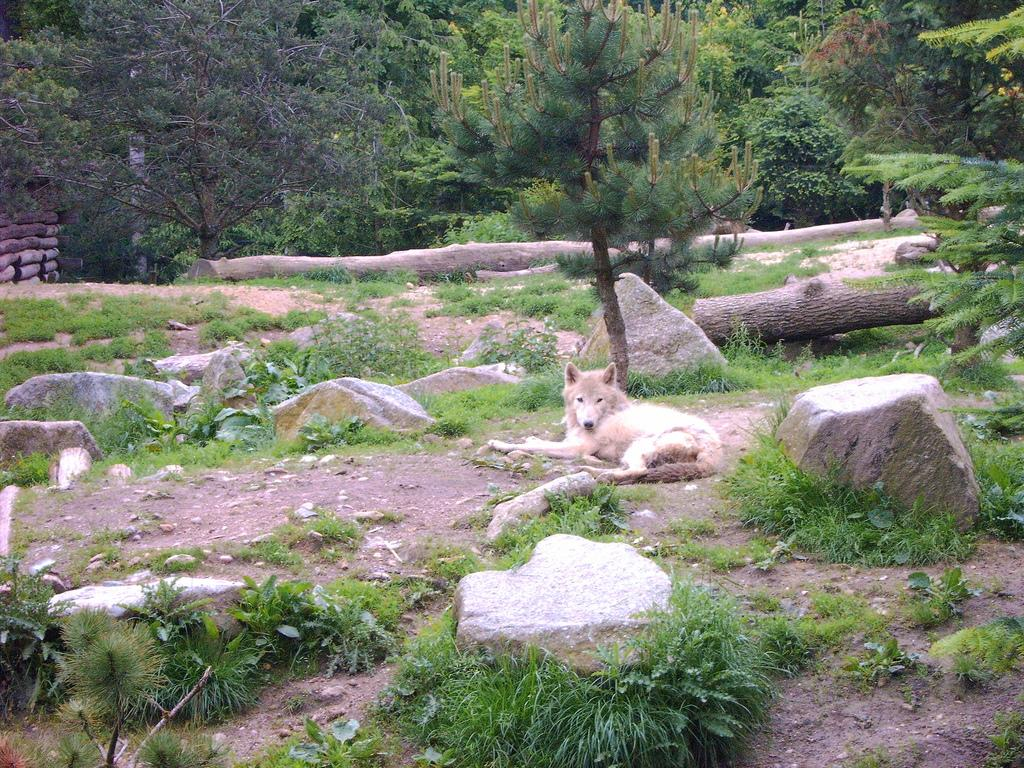What is the main subject of the image? There is an animal lying on the ground in the image. What type of terrain is visible in the image? There are stones and grass visible in the image. What can be seen in the background of the image? There are trees in the background of the image. What religion does the animal in the image practice? There is no indication of religion in the image, as it features an animal lying on the ground with stones, grass, and trees in the background. 